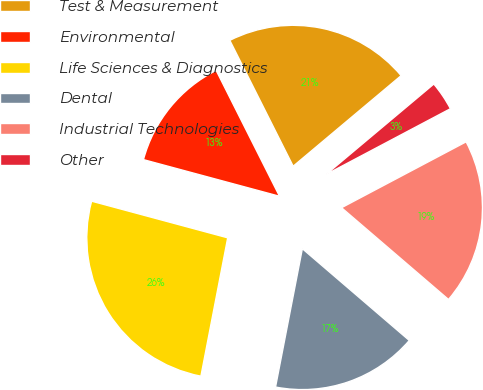Convert chart. <chart><loc_0><loc_0><loc_500><loc_500><pie_chart><fcel>Test & Measurement<fcel>Environmental<fcel>Life Sciences & Diagnostics<fcel>Dental<fcel>Industrial Technologies<fcel>Other<nl><fcel>21.31%<fcel>13.39%<fcel>26.14%<fcel>16.76%<fcel>19.03%<fcel>3.37%<nl></chart> 